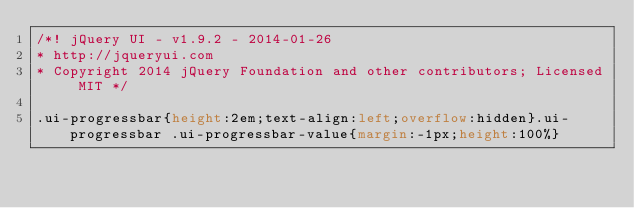<code> <loc_0><loc_0><loc_500><loc_500><_CSS_>/*! jQuery UI - v1.9.2 - 2014-01-26
* http://jqueryui.com
* Copyright 2014 jQuery Foundation and other contributors; Licensed MIT */

.ui-progressbar{height:2em;text-align:left;overflow:hidden}.ui-progressbar .ui-progressbar-value{margin:-1px;height:100%}</code> 